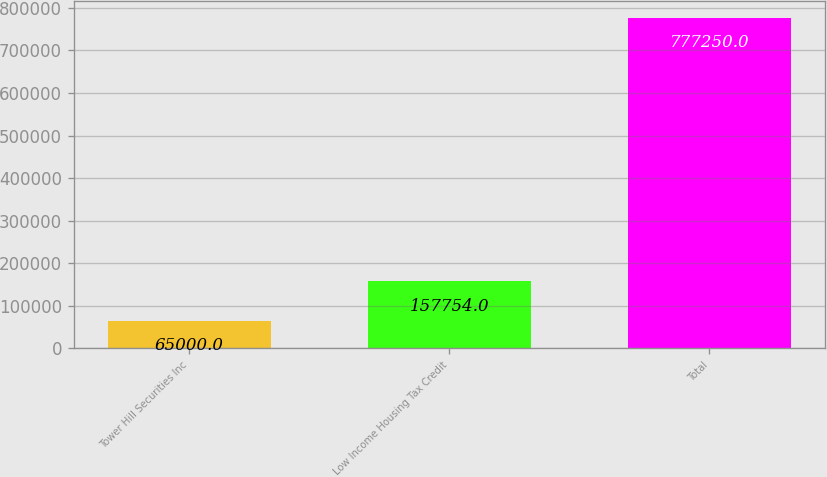Convert chart to OTSL. <chart><loc_0><loc_0><loc_500><loc_500><bar_chart><fcel>Tower Hill Securities Inc<fcel>Low Income Housing Tax Credit<fcel>Total<nl><fcel>65000<fcel>157754<fcel>777250<nl></chart> 